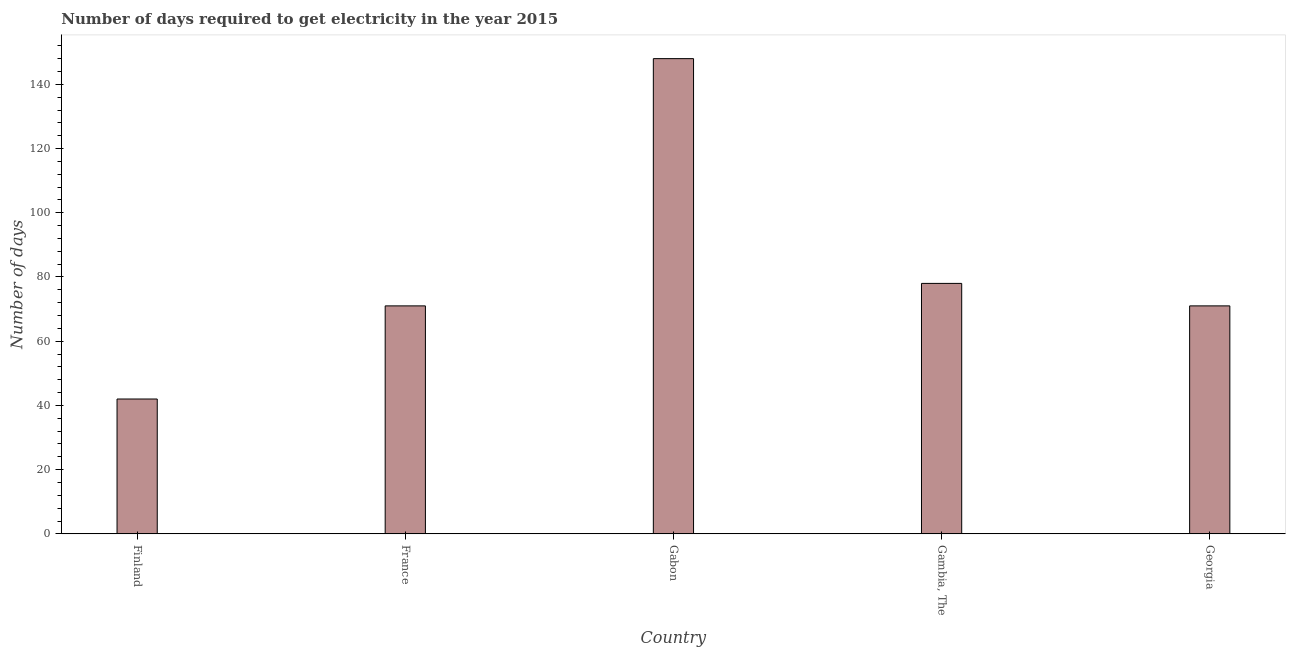Does the graph contain any zero values?
Your answer should be very brief. No. Does the graph contain grids?
Give a very brief answer. No. What is the title of the graph?
Give a very brief answer. Number of days required to get electricity in the year 2015. What is the label or title of the X-axis?
Provide a succinct answer. Country. What is the label or title of the Y-axis?
Your answer should be compact. Number of days. Across all countries, what is the maximum time to get electricity?
Ensure brevity in your answer.  148. In which country was the time to get electricity maximum?
Your answer should be compact. Gabon. In which country was the time to get electricity minimum?
Give a very brief answer. Finland. What is the sum of the time to get electricity?
Provide a short and direct response. 410. What is the difference between the time to get electricity in France and Gabon?
Give a very brief answer. -77. What is the average time to get electricity per country?
Your answer should be compact. 82. What is the median time to get electricity?
Offer a very short reply. 71. What is the ratio of the time to get electricity in Gambia, The to that in Georgia?
Keep it short and to the point. 1.1. Is the difference between the time to get electricity in France and Gambia, The greater than the difference between any two countries?
Provide a succinct answer. No. What is the difference between the highest and the second highest time to get electricity?
Provide a succinct answer. 70. What is the difference between the highest and the lowest time to get electricity?
Give a very brief answer. 106. In how many countries, is the time to get electricity greater than the average time to get electricity taken over all countries?
Ensure brevity in your answer.  1. How many bars are there?
Keep it short and to the point. 5. Are all the bars in the graph horizontal?
Offer a very short reply. No. How many countries are there in the graph?
Provide a short and direct response. 5. Are the values on the major ticks of Y-axis written in scientific E-notation?
Offer a very short reply. No. What is the Number of days in Gabon?
Provide a succinct answer. 148. What is the Number of days in Georgia?
Offer a very short reply. 71. What is the difference between the Number of days in Finland and Gabon?
Make the answer very short. -106. What is the difference between the Number of days in Finland and Gambia, The?
Give a very brief answer. -36. What is the difference between the Number of days in France and Gabon?
Make the answer very short. -77. What is the difference between the Number of days in France and Gambia, The?
Your answer should be very brief. -7. What is the difference between the Number of days in Gabon and Gambia, The?
Offer a very short reply. 70. What is the difference between the Number of days in Gabon and Georgia?
Ensure brevity in your answer.  77. What is the ratio of the Number of days in Finland to that in France?
Provide a succinct answer. 0.59. What is the ratio of the Number of days in Finland to that in Gabon?
Your answer should be very brief. 0.28. What is the ratio of the Number of days in Finland to that in Gambia, The?
Your answer should be compact. 0.54. What is the ratio of the Number of days in Finland to that in Georgia?
Ensure brevity in your answer.  0.59. What is the ratio of the Number of days in France to that in Gabon?
Ensure brevity in your answer.  0.48. What is the ratio of the Number of days in France to that in Gambia, The?
Your answer should be very brief. 0.91. What is the ratio of the Number of days in France to that in Georgia?
Your answer should be compact. 1. What is the ratio of the Number of days in Gabon to that in Gambia, The?
Offer a terse response. 1.9. What is the ratio of the Number of days in Gabon to that in Georgia?
Keep it short and to the point. 2.08. What is the ratio of the Number of days in Gambia, The to that in Georgia?
Ensure brevity in your answer.  1.1. 